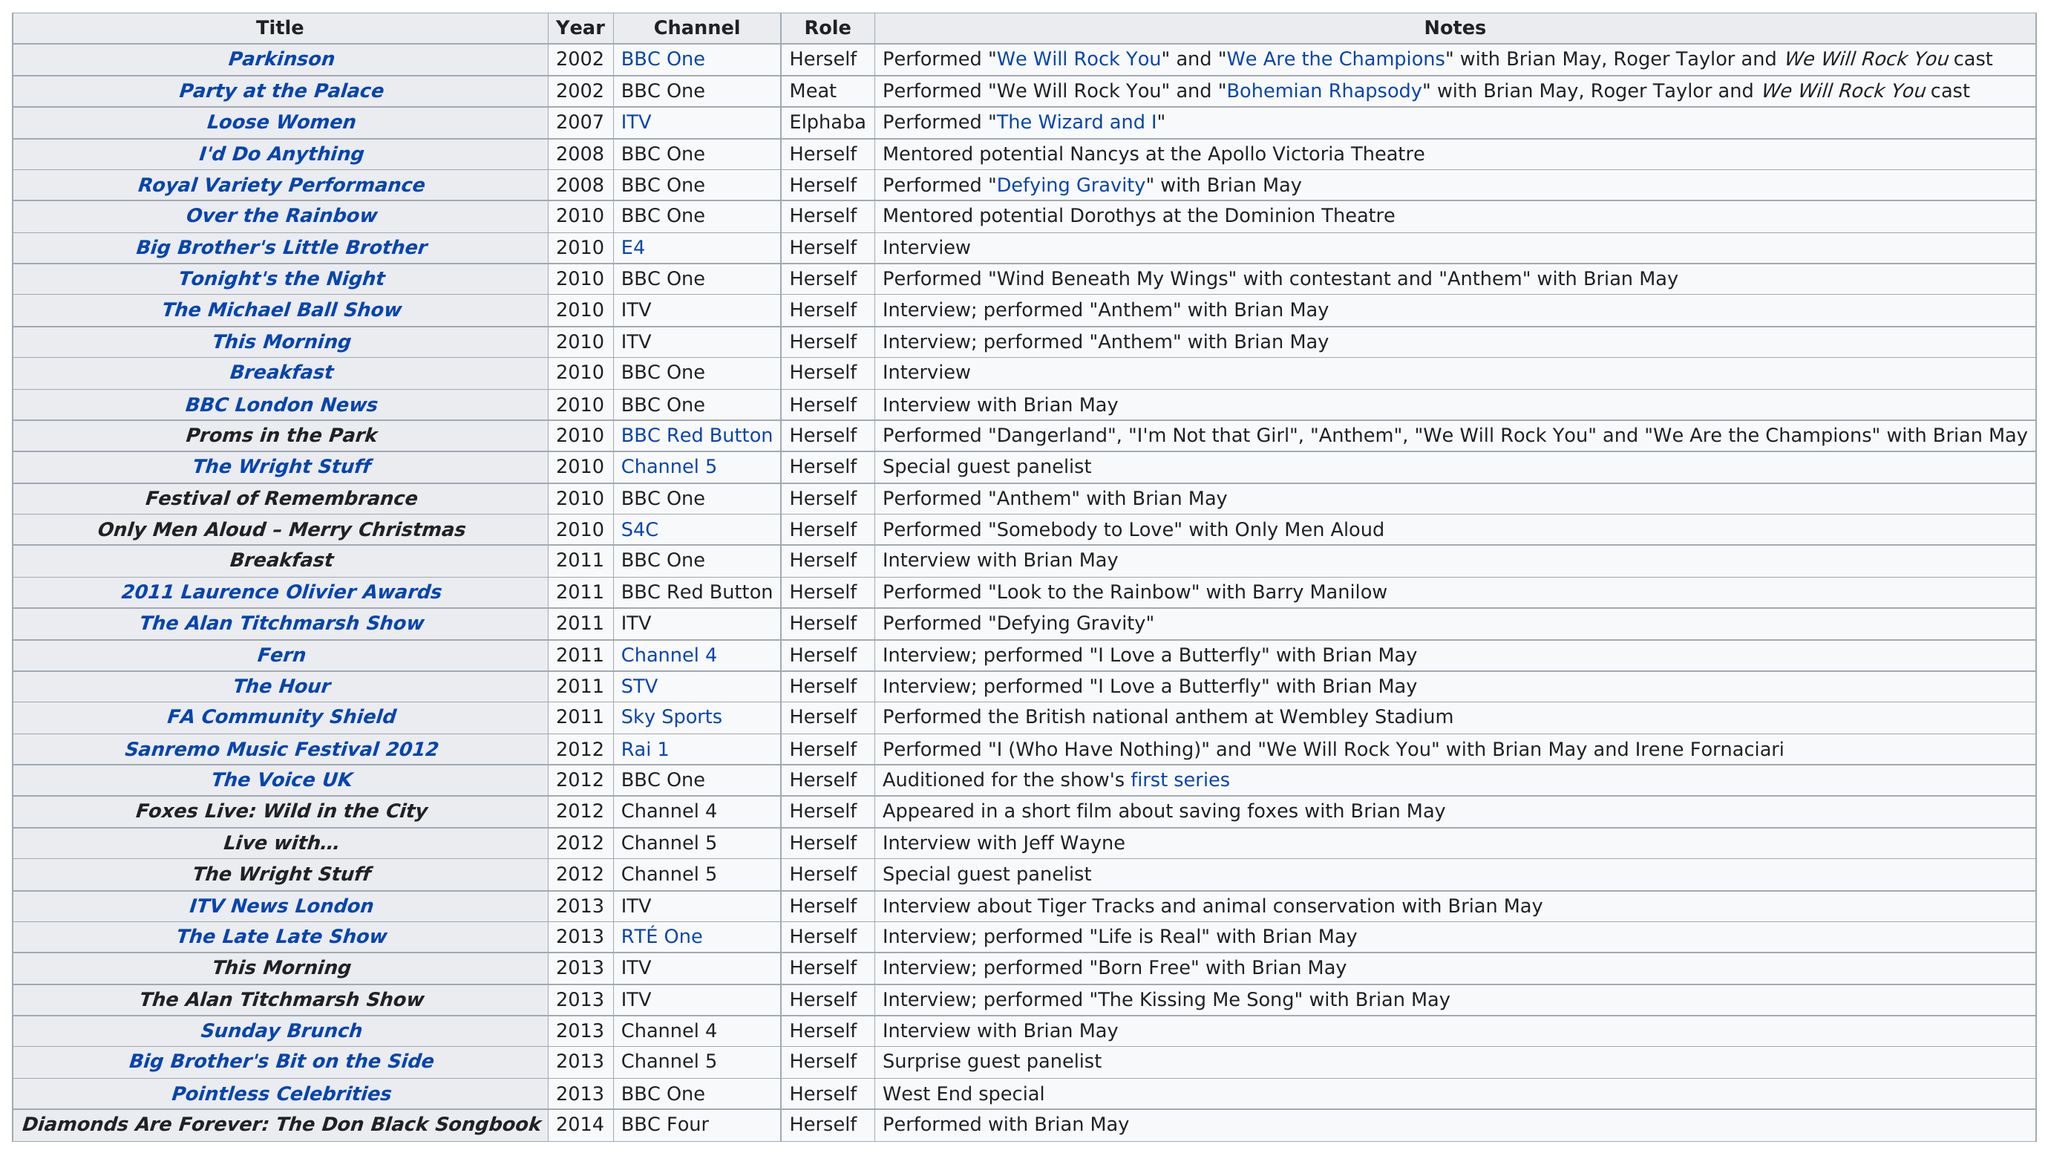Give some essential details in this illustration. In 2010, Kerry Ellis made 11 television appearances. The title of the last television appearance made by a person in 2010 was "Only Men Aloud - Merry Christmas.. She has played 33 roles, including one in which she played herself. Kerry Ellis' last television appearance was in "Diamonds Are Forever: The Don Black Songbook," which aired on television. Brian May has appeared on five consecutive televised performances by Kerry Ellis. 